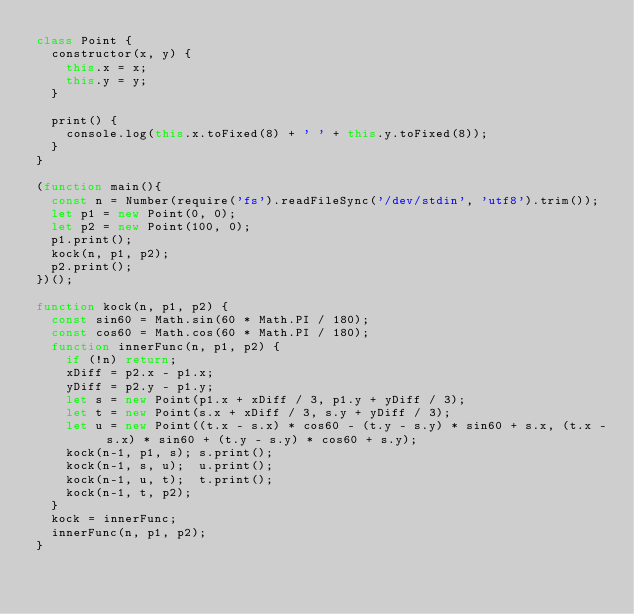Convert code to text. <code><loc_0><loc_0><loc_500><loc_500><_JavaScript_>class Point {
  constructor(x, y) {
    this.x = x;
    this.y = y;
  }

  print() {
    console.log(this.x.toFixed(8) + ' ' + this.y.toFixed(8));
  }
}

(function main(){
  const n = Number(require('fs').readFileSync('/dev/stdin', 'utf8').trim());
  let p1 = new Point(0, 0);
  let p2 = new Point(100, 0);
  p1.print();
  kock(n, p1, p2);
  p2.print();
})();

function kock(n, p1, p2) {
  const sin60 = Math.sin(60 * Math.PI / 180);
  const cos60 = Math.cos(60 * Math.PI / 180);
  function innerFunc(n, p1, p2) {
    if (!n) return;
    xDiff = p2.x - p1.x;
    yDiff = p2.y - p1.y;
    let s = new Point(p1.x + xDiff / 3, p1.y + yDiff / 3);
    let t = new Point(s.x + xDiff / 3, s.y + yDiff / 3);
    let u = new Point((t.x - s.x) * cos60 - (t.y - s.y) * sin60 + s.x, (t.x - s.x) * sin60 + (t.y - s.y) * cos60 + s.y);
    kock(n-1, p1, s); s.print();
    kock(n-1, s, u);  u.print();
    kock(n-1, u, t);  t.print();
    kock(n-1, t, p2);
  }
  kock = innerFunc;
  innerFunc(n, p1, p2);
}

</code> 